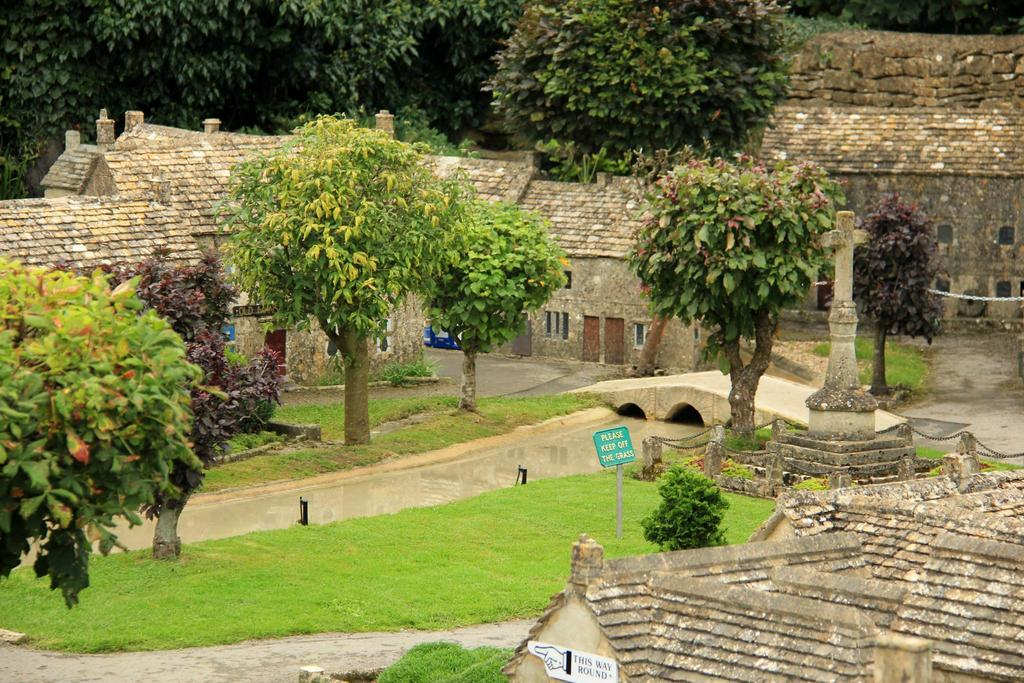What type of vegetation is present in the image? There are many trees and grass in the image. What structures can be seen behind the trees? There are houses behind the trees. What is located behind the houses in the image? There is a thicket behind the houses. What type of rail can be seen in the image? There is no rail present in the image. Does the existence of the trees in the image prove the existence of a parallel universe? The presence of trees in the image does not prove the existence of a parallel universe; it is simply a natural landscape. 